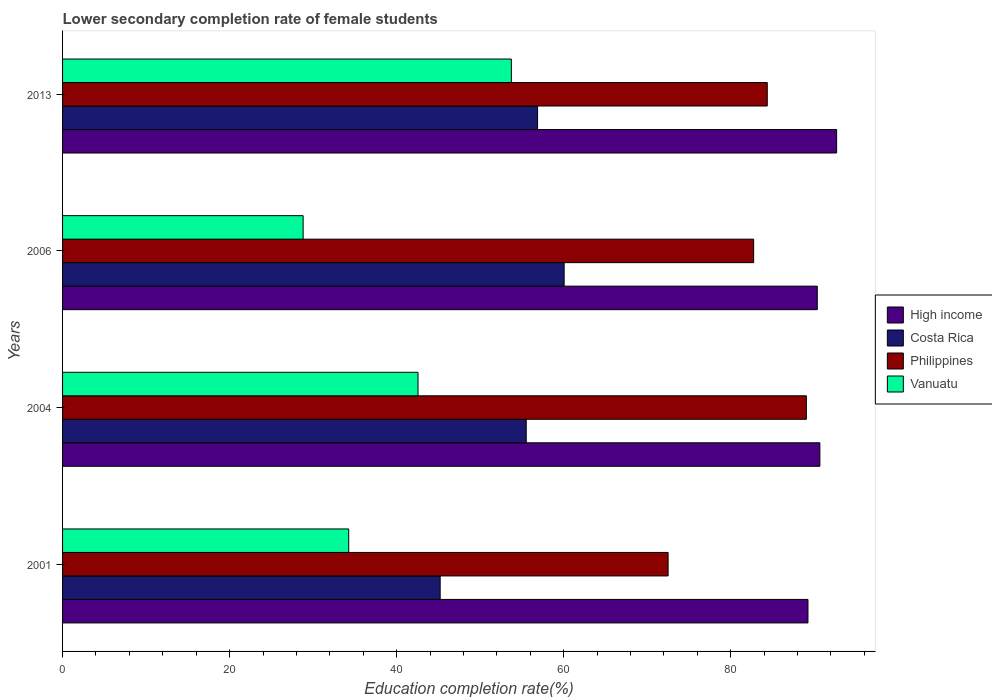How many different coloured bars are there?
Provide a succinct answer. 4. How many groups of bars are there?
Keep it short and to the point. 4. Are the number of bars on each tick of the Y-axis equal?
Your response must be concise. Yes. How many bars are there on the 4th tick from the top?
Provide a succinct answer. 4. How many bars are there on the 4th tick from the bottom?
Offer a terse response. 4. In how many cases, is the number of bars for a given year not equal to the number of legend labels?
Ensure brevity in your answer.  0. What is the lower secondary completion rate of female students in Costa Rica in 2004?
Your response must be concise. 55.52. Across all years, what is the maximum lower secondary completion rate of female students in High income?
Offer a terse response. 92.68. Across all years, what is the minimum lower secondary completion rate of female students in High income?
Offer a very short reply. 89.25. In which year was the lower secondary completion rate of female students in Vanuatu minimum?
Offer a terse response. 2006. What is the total lower secondary completion rate of female students in High income in the graph?
Offer a very short reply. 362.97. What is the difference between the lower secondary completion rate of female students in Vanuatu in 2001 and that in 2006?
Your answer should be compact. 5.46. What is the difference between the lower secondary completion rate of female students in High income in 2004 and the lower secondary completion rate of female students in Philippines in 2013?
Your response must be concise. 6.3. What is the average lower secondary completion rate of female students in Vanuatu per year?
Offer a very short reply. 39.84. In the year 2001, what is the difference between the lower secondary completion rate of female students in Vanuatu and lower secondary completion rate of female students in Philippines?
Offer a very short reply. -38.24. In how many years, is the lower secondary completion rate of female students in Costa Rica greater than 72 %?
Provide a succinct answer. 0. What is the ratio of the lower secondary completion rate of female students in Costa Rica in 2001 to that in 2006?
Give a very brief answer. 0.75. What is the difference between the highest and the second highest lower secondary completion rate of female students in Vanuatu?
Provide a succinct answer. 11.17. What is the difference between the highest and the lowest lower secondary completion rate of female students in Vanuatu?
Provide a short and direct response. 24.93. Is it the case that in every year, the sum of the lower secondary completion rate of female students in Costa Rica and lower secondary completion rate of female students in Philippines is greater than the sum of lower secondary completion rate of female students in Vanuatu and lower secondary completion rate of female students in High income?
Provide a succinct answer. No. How many bars are there?
Provide a succinct answer. 16. Are all the bars in the graph horizontal?
Offer a very short reply. Yes. What is the difference between two consecutive major ticks on the X-axis?
Offer a terse response. 20. Are the values on the major ticks of X-axis written in scientific E-notation?
Your response must be concise. No. Does the graph contain any zero values?
Keep it short and to the point. No. How many legend labels are there?
Give a very brief answer. 4. What is the title of the graph?
Offer a terse response. Lower secondary completion rate of female students. Does "Dominica" appear as one of the legend labels in the graph?
Offer a very short reply. No. What is the label or title of the X-axis?
Your answer should be compact. Education completion rate(%). What is the label or title of the Y-axis?
Ensure brevity in your answer.  Years. What is the Education completion rate(%) in High income in 2001?
Provide a succinct answer. 89.25. What is the Education completion rate(%) of Costa Rica in 2001?
Your answer should be very brief. 45.21. What is the Education completion rate(%) of Philippines in 2001?
Give a very brief answer. 72.5. What is the Education completion rate(%) in Vanuatu in 2001?
Offer a terse response. 34.26. What is the Education completion rate(%) in High income in 2004?
Keep it short and to the point. 90.67. What is the Education completion rate(%) of Costa Rica in 2004?
Keep it short and to the point. 55.52. What is the Education completion rate(%) in Philippines in 2004?
Your answer should be very brief. 89.05. What is the Education completion rate(%) of Vanuatu in 2004?
Your response must be concise. 42.56. What is the Education completion rate(%) of High income in 2006?
Make the answer very short. 90.36. What is the Education completion rate(%) of Costa Rica in 2006?
Your answer should be very brief. 60.06. What is the Education completion rate(%) in Philippines in 2006?
Keep it short and to the point. 82.75. What is the Education completion rate(%) in Vanuatu in 2006?
Give a very brief answer. 28.8. What is the Education completion rate(%) of High income in 2013?
Provide a short and direct response. 92.68. What is the Education completion rate(%) in Costa Rica in 2013?
Your answer should be very brief. 56.87. What is the Education completion rate(%) in Philippines in 2013?
Offer a terse response. 84.38. What is the Education completion rate(%) of Vanuatu in 2013?
Keep it short and to the point. 53.73. Across all years, what is the maximum Education completion rate(%) of High income?
Give a very brief answer. 92.68. Across all years, what is the maximum Education completion rate(%) of Costa Rica?
Offer a terse response. 60.06. Across all years, what is the maximum Education completion rate(%) of Philippines?
Make the answer very short. 89.05. Across all years, what is the maximum Education completion rate(%) of Vanuatu?
Your answer should be very brief. 53.73. Across all years, what is the minimum Education completion rate(%) of High income?
Offer a very short reply. 89.25. Across all years, what is the minimum Education completion rate(%) of Costa Rica?
Make the answer very short. 45.21. Across all years, what is the minimum Education completion rate(%) of Philippines?
Provide a short and direct response. 72.5. Across all years, what is the minimum Education completion rate(%) in Vanuatu?
Provide a succinct answer. 28.8. What is the total Education completion rate(%) in High income in the graph?
Offer a very short reply. 362.97. What is the total Education completion rate(%) of Costa Rica in the graph?
Provide a succinct answer. 217.66. What is the total Education completion rate(%) in Philippines in the graph?
Your answer should be compact. 328.68. What is the total Education completion rate(%) in Vanuatu in the graph?
Ensure brevity in your answer.  159.36. What is the difference between the Education completion rate(%) of High income in 2001 and that in 2004?
Your response must be concise. -1.43. What is the difference between the Education completion rate(%) in Costa Rica in 2001 and that in 2004?
Ensure brevity in your answer.  -10.31. What is the difference between the Education completion rate(%) of Philippines in 2001 and that in 2004?
Provide a short and direct response. -16.55. What is the difference between the Education completion rate(%) of Vanuatu in 2001 and that in 2004?
Give a very brief answer. -8.3. What is the difference between the Education completion rate(%) of High income in 2001 and that in 2006?
Make the answer very short. -1.11. What is the difference between the Education completion rate(%) in Costa Rica in 2001 and that in 2006?
Offer a very short reply. -14.84. What is the difference between the Education completion rate(%) in Philippines in 2001 and that in 2006?
Provide a short and direct response. -10.24. What is the difference between the Education completion rate(%) in Vanuatu in 2001 and that in 2006?
Your response must be concise. 5.46. What is the difference between the Education completion rate(%) of High income in 2001 and that in 2013?
Your answer should be compact. -3.43. What is the difference between the Education completion rate(%) in Costa Rica in 2001 and that in 2013?
Give a very brief answer. -11.66. What is the difference between the Education completion rate(%) in Philippines in 2001 and that in 2013?
Ensure brevity in your answer.  -11.87. What is the difference between the Education completion rate(%) of Vanuatu in 2001 and that in 2013?
Keep it short and to the point. -19.47. What is the difference between the Education completion rate(%) of High income in 2004 and that in 2006?
Offer a very short reply. 0.31. What is the difference between the Education completion rate(%) in Costa Rica in 2004 and that in 2006?
Offer a terse response. -4.54. What is the difference between the Education completion rate(%) in Philippines in 2004 and that in 2006?
Give a very brief answer. 6.31. What is the difference between the Education completion rate(%) of Vanuatu in 2004 and that in 2006?
Ensure brevity in your answer.  13.76. What is the difference between the Education completion rate(%) in High income in 2004 and that in 2013?
Ensure brevity in your answer.  -2.01. What is the difference between the Education completion rate(%) in Costa Rica in 2004 and that in 2013?
Offer a very short reply. -1.36. What is the difference between the Education completion rate(%) of Philippines in 2004 and that in 2013?
Offer a very short reply. 4.68. What is the difference between the Education completion rate(%) in Vanuatu in 2004 and that in 2013?
Your answer should be very brief. -11.17. What is the difference between the Education completion rate(%) in High income in 2006 and that in 2013?
Offer a very short reply. -2.32. What is the difference between the Education completion rate(%) in Costa Rica in 2006 and that in 2013?
Your answer should be compact. 3.18. What is the difference between the Education completion rate(%) of Philippines in 2006 and that in 2013?
Make the answer very short. -1.63. What is the difference between the Education completion rate(%) in Vanuatu in 2006 and that in 2013?
Keep it short and to the point. -24.93. What is the difference between the Education completion rate(%) of High income in 2001 and the Education completion rate(%) of Costa Rica in 2004?
Keep it short and to the point. 33.73. What is the difference between the Education completion rate(%) in High income in 2001 and the Education completion rate(%) in Philippines in 2004?
Give a very brief answer. 0.19. What is the difference between the Education completion rate(%) in High income in 2001 and the Education completion rate(%) in Vanuatu in 2004?
Make the answer very short. 46.69. What is the difference between the Education completion rate(%) in Costa Rica in 2001 and the Education completion rate(%) in Philippines in 2004?
Make the answer very short. -43.84. What is the difference between the Education completion rate(%) in Costa Rica in 2001 and the Education completion rate(%) in Vanuatu in 2004?
Your answer should be very brief. 2.65. What is the difference between the Education completion rate(%) in Philippines in 2001 and the Education completion rate(%) in Vanuatu in 2004?
Make the answer very short. 29.94. What is the difference between the Education completion rate(%) of High income in 2001 and the Education completion rate(%) of Costa Rica in 2006?
Your answer should be compact. 29.19. What is the difference between the Education completion rate(%) in High income in 2001 and the Education completion rate(%) in Philippines in 2006?
Provide a short and direct response. 6.5. What is the difference between the Education completion rate(%) of High income in 2001 and the Education completion rate(%) of Vanuatu in 2006?
Your answer should be compact. 60.44. What is the difference between the Education completion rate(%) in Costa Rica in 2001 and the Education completion rate(%) in Philippines in 2006?
Provide a short and direct response. -37.53. What is the difference between the Education completion rate(%) of Costa Rica in 2001 and the Education completion rate(%) of Vanuatu in 2006?
Provide a short and direct response. 16.41. What is the difference between the Education completion rate(%) of Philippines in 2001 and the Education completion rate(%) of Vanuatu in 2006?
Ensure brevity in your answer.  43.7. What is the difference between the Education completion rate(%) of High income in 2001 and the Education completion rate(%) of Costa Rica in 2013?
Your response must be concise. 32.37. What is the difference between the Education completion rate(%) in High income in 2001 and the Education completion rate(%) in Philippines in 2013?
Ensure brevity in your answer.  4.87. What is the difference between the Education completion rate(%) in High income in 2001 and the Education completion rate(%) in Vanuatu in 2013?
Your response must be concise. 35.51. What is the difference between the Education completion rate(%) of Costa Rica in 2001 and the Education completion rate(%) of Philippines in 2013?
Your answer should be compact. -39.16. What is the difference between the Education completion rate(%) of Costa Rica in 2001 and the Education completion rate(%) of Vanuatu in 2013?
Ensure brevity in your answer.  -8.52. What is the difference between the Education completion rate(%) in Philippines in 2001 and the Education completion rate(%) in Vanuatu in 2013?
Your answer should be compact. 18.77. What is the difference between the Education completion rate(%) of High income in 2004 and the Education completion rate(%) of Costa Rica in 2006?
Your response must be concise. 30.62. What is the difference between the Education completion rate(%) in High income in 2004 and the Education completion rate(%) in Philippines in 2006?
Your answer should be compact. 7.93. What is the difference between the Education completion rate(%) of High income in 2004 and the Education completion rate(%) of Vanuatu in 2006?
Provide a short and direct response. 61.87. What is the difference between the Education completion rate(%) of Costa Rica in 2004 and the Education completion rate(%) of Philippines in 2006?
Provide a short and direct response. -27.23. What is the difference between the Education completion rate(%) in Costa Rica in 2004 and the Education completion rate(%) in Vanuatu in 2006?
Your answer should be compact. 26.71. What is the difference between the Education completion rate(%) in Philippines in 2004 and the Education completion rate(%) in Vanuatu in 2006?
Make the answer very short. 60.25. What is the difference between the Education completion rate(%) in High income in 2004 and the Education completion rate(%) in Costa Rica in 2013?
Your answer should be compact. 33.8. What is the difference between the Education completion rate(%) in High income in 2004 and the Education completion rate(%) in Philippines in 2013?
Your answer should be very brief. 6.3. What is the difference between the Education completion rate(%) in High income in 2004 and the Education completion rate(%) in Vanuatu in 2013?
Your answer should be compact. 36.94. What is the difference between the Education completion rate(%) of Costa Rica in 2004 and the Education completion rate(%) of Philippines in 2013?
Give a very brief answer. -28.86. What is the difference between the Education completion rate(%) in Costa Rica in 2004 and the Education completion rate(%) in Vanuatu in 2013?
Ensure brevity in your answer.  1.78. What is the difference between the Education completion rate(%) of Philippines in 2004 and the Education completion rate(%) of Vanuatu in 2013?
Ensure brevity in your answer.  35.32. What is the difference between the Education completion rate(%) in High income in 2006 and the Education completion rate(%) in Costa Rica in 2013?
Ensure brevity in your answer.  33.49. What is the difference between the Education completion rate(%) of High income in 2006 and the Education completion rate(%) of Philippines in 2013?
Provide a short and direct response. 5.99. What is the difference between the Education completion rate(%) of High income in 2006 and the Education completion rate(%) of Vanuatu in 2013?
Ensure brevity in your answer.  36.63. What is the difference between the Education completion rate(%) in Costa Rica in 2006 and the Education completion rate(%) in Philippines in 2013?
Give a very brief answer. -24.32. What is the difference between the Education completion rate(%) of Costa Rica in 2006 and the Education completion rate(%) of Vanuatu in 2013?
Ensure brevity in your answer.  6.32. What is the difference between the Education completion rate(%) of Philippines in 2006 and the Education completion rate(%) of Vanuatu in 2013?
Make the answer very short. 29.01. What is the average Education completion rate(%) in High income per year?
Your answer should be very brief. 90.74. What is the average Education completion rate(%) of Costa Rica per year?
Offer a very short reply. 54.41. What is the average Education completion rate(%) of Philippines per year?
Offer a very short reply. 82.17. What is the average Education completion rate(%) in Vanuatu per year?
Give a very brief answer. 39.84. In the year 2001, what is the difference between the Education completion rate(%) of High income and Education completion rate(%) of Costa Rica?
Keep it short and to the point. 44.04. In the year 2001, what is the difference between the Education completion rate(%) in High income and Education completion rate(%) in Philippines?
Give a very brief answer. 16.75. In the year 2001, what is the difference between the Education completion rate(%) of High income and Education completion rate(%) of Vanuatu?
Your answer should be compact. 54.99. In the year 2001, what is the difference between the Education completion rate(%) of Costa Rica and Education completion rate(%) of Philippines?
Give a very brief answer. -27.29. In the year 2001, what is the difference between the Education completion rate(%) of Costa Rica and Education completion rate(%) of Vanuatu?
Your answer should be compact. 10.95. In the year 2001, what is the difference between the Education completion rate(%) of Philippines and Education completion rate(%) of Vanuatu?
Your response must be concise. 38.24. In the year 2004, what is the difference between the Education completion rate(%) of High income and Education completion rate(%) of Costa Rica?
Ensure brevity in your answer.  35.16. In the year 2004, what is the difference between the Education completion rate(%) of High income and Education completion rate(%) of Philippines?
Ensure brevity in your answer.  1.62. In the year 2004, what is the difference between the Education completion rate(%) in High income and Education completion rate(%) in Vanuatu?
Ensure brevity in your answer.  48.11. In the year 2004, what is the difference between the Education completion rate(%) in Costa Rica and Education completion rate(%) in Philippines?
Your answer should be very brief. -33.54. In the year 2004, what is the difference between the Education completion rate(%) in Costa Rica and Education completion rate(%) in Vanuatu?
Ensure brevity in your answer.  12.96. In the year 2004, what is the difference between the Education completion rate(%) in Philippines and Education completion rate(%) in Vanuatu?
Provide a succinct answer. 46.49. In the year 2006, what is the difference between the Education completion rate(%) in High income and Education completion rate(%) in Costa Rica?
Offer a very short reply. 30.31. In the year 2006, what is the difference between the Education completion rate(%) in High income and Education completion rate(%) in Philippines?
Provide a succinct answer. 7.62. In the year 2006, what is the difference between the Education completion rate(%) of High income and Education completion rate(%) of Vanuatu?
Give a very brief answer. 61.56. In the year 2006, what is the difference between the Education completion rate(%) in Costa Rica and Education completion rate(%) in Philippines?
Offer a very short reply. -22.69. In the year 2006, what is the difference between the Education completion rate(%) in Costa Rica and Education completion rate(%) in Vanuatu?
Offer a terse response. 31.25. In the year 2006, what is the difference between the Education completion rate(%) in Philippines and Education completion rate(%) in Vanuatu?
Provide a short and direct response. 53.94. In the year 2013, what is the difference between the Education completion rate(%) of High income and Education completion rate(%) of Costa Rica?
Keep it short and to the point. 35.81. In the year 2013, what is the difference between the Education completion rate(%) in High income and Education completion rate(%) in Philippines?
Your response must be concise. 8.31. In the year 2013, what is the difference between the Education completion rate(%) in High income and Education completion rate(%) in Vanuatu?
Ensure brevity in your answer.  38.95. In the year 2013, what is the difference between the Education completion rate(%) in Costa Rica and Education completion rate(%) in Philippines?
Offer a terse response. -27.5. In the year 2013, what is the difference between the Education completion rate(%) of Costa Rica and Education completion rate(%) of Vanuatu?
Provide a succinct answer. 3.14. In the year 2013, what is the difference between the Education completion rate(%) of Philippines and Education completion rate(%) of Vanuatu?
Provide a succinct answer. 30.64. What is the ratio of the Education completion rate(%) of High income in 2001 to that in 2004?
Offer a terse response. 0.98. What is the ratio of the Education completion rate(%) of Costa Rica in 2001 to that in 2004?
Make the answer very short. 0.81. What is the ratio of the Education completion rate(%) in Philippines in 2001 to that in 2004?
Provide a short and direct response. 0.81. What is the ratio of the Education completion rate(%) of Vanuatu in 2001 to that in 2004?
Give a very brief answer. 0.81. What is the ratio of the Education completion rate(%) of High income in 2001 to that in 2006?
Provide a short and direct response. 0.99. What is the ratio of the Education completion rate(%) of Costa Rica in 2001 to that in 2006?
Provide a succinct answer. 0.75. What is the ratio of the Education completion rate(%) in Philippines in 2001 to that in 2006?
Your answer should be very brief. 0.88. What is the ratio of the Education completion rate(%) of Vanuatu in 2001 to that in 2006?
Provide a short and direct response. 1.19. What is the ratio of the Education completion rate(%) of High income in 2001 to that in 2013?
Ensure brevity in your answer.  0.96. What is the ratio of the Education completion rate(%) of Costa Rica in 2001 to that in 2013?
Provide a succinct answer. 0.79. What is the ratio of the Education completion rate(%) of Philippines in 2001 to that in 2013?
Offer a very short reply. 0.86. What is the ratio of the Education completion rate(%) in Vanuatu in 2001 to that in 2013?
Your answer should be very brief. 0.64. What is the ratio of the Education completion rate(%) in Costa Rica in 2004 to that in 2006?
Your response must be concise. 0.92. What is the ratio of the Education completion rate(%) in Philippines in 2004 to that in 2006?
Your answer should be compact. 1.08. What is the ratio of the Education completion rate(%) of Vanuatu in 2004 to that in 2006?
Your answer should be compact. 1.48. What is the ratio of the Education completion rate(%) of High income in 2004 to that in 2013?
Offer a terse response. 0.98. What is the ratio of the Education completion rate(%) of Costa Rica in 2004 to that in 2013?
Offer a very short reply. 0.98. What is the ratio of the Education completion rate(%) in Philippines in 2004 to that in 2013?
Keep it short and to the point. 1.06. What is the ratio of the Education completion rate(%) in Vanuatu in 2004 to that in 2013?
Your answer should be very brief. 0.79. What is the ratio of the Education completion rate(%) of High income in 2006 to that in 2013?
Provide a succinct answer. 0.97. What is the ratio of the Education completion rate(%) of Costa Rica in 2006 to that in 2013?
Ensure brevity in your answer.  1.06. What is the ratio of the Education completion rate(%) in Philippines in 2006 to that in 2013?
Make the answer very short. 0.98. What is the ratio of the Education completion rate(%) of Vanuatu in 2006 to that in 2013?
Your answer should be very brief. 0.54. What is the difference between the highest and the second highest Education completion rate(%) in High income?
Offer a very short reply. 2.01. What is the difference between the highest and the second highest Education completion rate(%) in Costa Rica?
Ensure brevity in your answer.  3.18. What is the difference between the highest and the second highest Education completion rate(%) of Philippines?
Offer a terse response. 4.68. What is the difference between the highest and the second highest Education completion rate(%) in Vanuatu?
Your response must be concise. 11.17. What is the difference between the highest and the lowest Education completion rate(%) of High income?
Offer a very short reply. 3.43. What is the difference between the highest and the lowest Education completion rate(%) of Costa Rica?
Offer a very short reply. 14.84. What is the difference between the highest and the lowest Education completion rate(%) in Philippines?
Offer a terse response. 16.55. What is the difference between the highest and the lowest Education completion rate(%) in Vanuatu?
Your answer should be very brief. 24.93. 